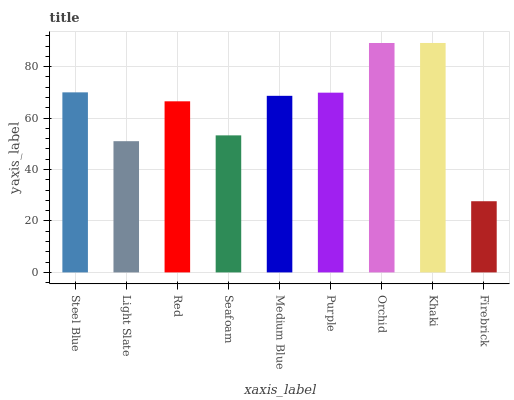Is Firebrick the minimum?
Answer yes or no. Yes. Is Khaki the maximum?
Answer yes or no. Yes. Is Light Slate the minimum?
Answer yes or no. No. Is Light Slate the maximum?
Answer yes or no. No. Is Steel Blue greater than Light Slate?
Answer yes or no. Yes. Is Light Slate less than Steel Blue?
Answer yes or no. Yes. Is Light Slate greater than Steel Blue?
Answer yes or no. No. Is Steel Blue less than Light Slate?
Answer yes or no. No. Is Medium Blue the high median?
Answer yes or no. Yes. Is Medium Blue the low median?
Answer yes or no. Yes. Is Firebrick the high median?
Answer yes or no. No. Is Khaki the low median?
Answer yes or no. No. 